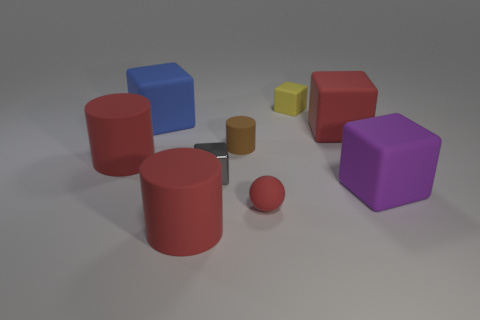Are there any other things that are the same shape as the small red thing?
Offer a very short reply. No. How many matte objects are blocks or tiny balls?
Ensure brevity in your answer.  5. Is there a small brown shiny thing?
Provide a succinct answer. No. Do the small gray object and the large purple object have the same shape?
Give a very brief answer. Yes. How many objects are left of the red matte cylinder on the right side of the large rubber cylinder that is to the left of the big blue object?
Make the answer very short. 2. The block that is on the right side of the tiny gray thing and behind the red block is made of what material?
Provide a short and direct response. Rubber. There is a big block that is to the right of the brown cylinder and behind the big purple block; what color is it?
Ensure brevity in your answer.  Red. Is there any other thing that has the same color as the sphere?
Provide a short and direct response. Yes. What is the shape of the big red rubber thing in front of the large red thing that is to the left of the big red matte cylinder in front of the tiny gray metal cube?
Your response must be concise. Cylinder. There is another metal thing that is the same shape as the yellow thing; what color is it?
Your answer should be compact. Gray. 